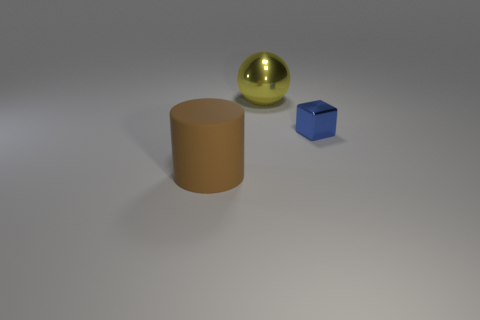Are there more balls that are in front of the big rubber cylinder than large yellow balls behind the yellow shiny thing?
Your answer should be compact. No. The blue object has what size?
Provide a succinct answer. Small. There is a yellow object that is made of the same material as the small blue block; what shape is it?
Your answer should be very brief. Sphere. There is a big object that is on the left side of the big yellow thing; does it have the same shape as the tiny blue object?
Offer a terse response. No. How many objects are either small metallic spheres or large objects?
Make the answer very short. 2. What material is the thing that is behind the brown rubber object and in front of the large yellow sphere?
Provide a short and direct response. Metal. Does the metal ball have the same size as the blue block?
Offer a very short reply. No. There is a brown matte cylinder that is to the left of the big thing right of the big brown cylinder; what is its size?
Provide a succinct answer. Large. How many objects are behind the small block and on the left side of the ball?
Your answer should be very brief. 0. Are there any large matte cylinders to the left of the thing to the left of the metallic ball that is to the left of the blue thing?
Your response must be concise. No. 